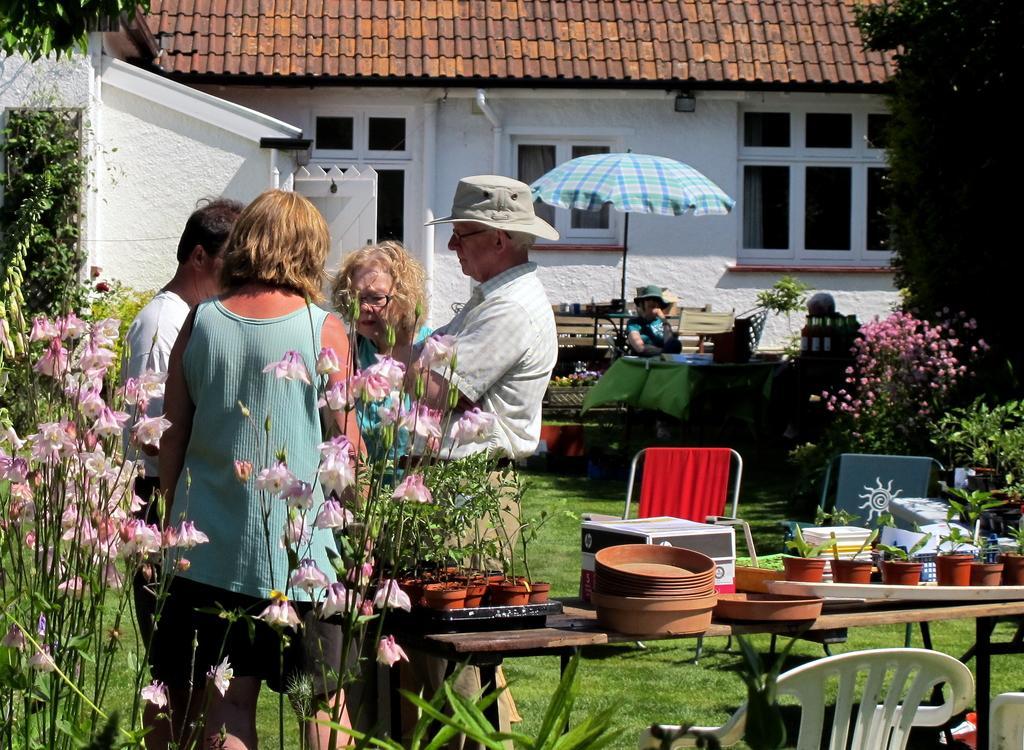Please provide a concise description of this image. In this image there are group of people standing behind the table and there are two persons sitting beside the table. There are pot, plants on the table. At the back there are two different chairs. There are trees at the right and left side of the image. At the back there is a building with roof tiles on the top and there is an umbrella in the middle of the image. 